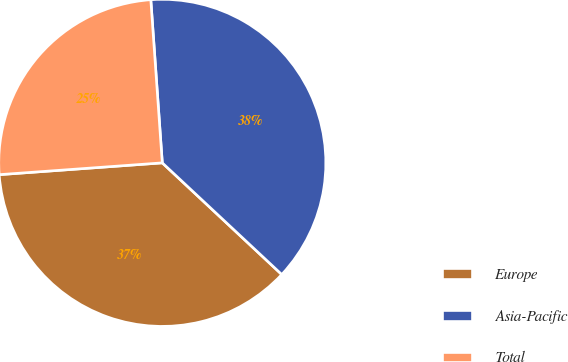Convert chart to OTSL. <chart><loc_0><loc_0><loc_500><loc_500><pie_chart><fcel>Europe<fcel>Asia-Pacific<fcel>Total<nl><fcel>36.89%<fcel>38.08%<fcel>25.03%<nl></chart> 